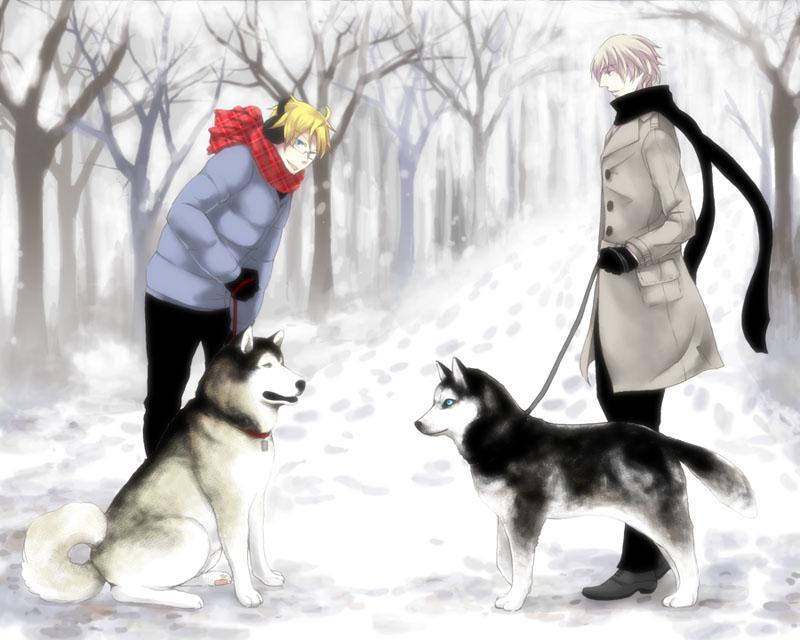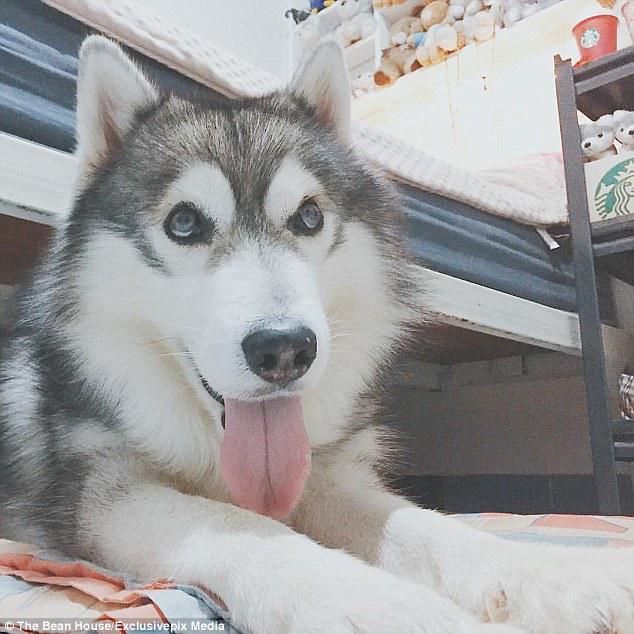The first image is the image on the left, the second image is the image on the right. Considering the images on both sides, is "One image shows dogs hitched to a sled with a driver standing behind it and moving in a forward direction." valid? Answer yes or no. No. 